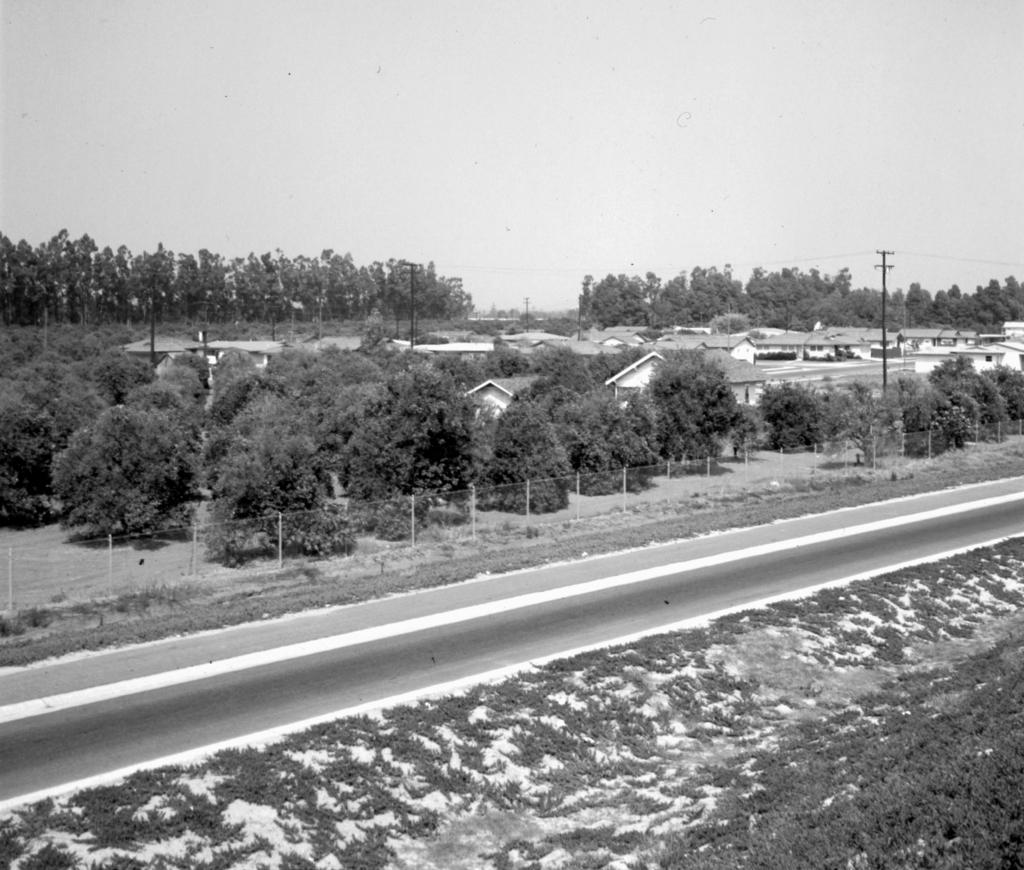What is the color scheme of the image? The image is black and white. What type of natural elements can be seen in the image? There are trees, plants, grass, and snow visible in the image. What type of structures are present in the image? There are houses and poles visible in the image. What type of man-made objects can be seen in the image? There are rods and a road visible in the image. What is visible at the top of the image? The sky is visible at the top of the image. What type of pancake is being served to the stranger in the image? There is no pancake or stranger present in the image. What is the friction between the rods and the snow in the image? The image does not depict any interaction between the rods and the snow, so it is not possible to determine the friction between them. 